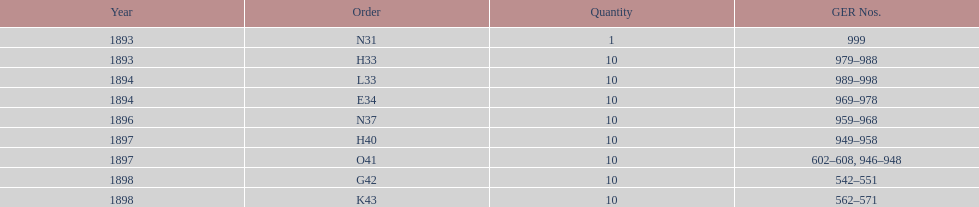What's the cumulative number of locomotives created throughout this time frame? 81. 